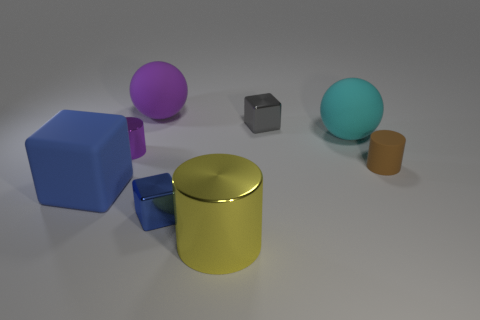Add 2 purple rubber objects. How many objects exist? 10 Subtract all balls. How many objects are left? 6 Add 2 brown rubber objects. How many brown rubber objects are left? 3 Add 4 small gray cubes. How many small gray cubes exist? 5 Subtract 1 purple balls. How many objects are left? 7 Subtract all cyan rubber spheres. Subtract all purple matte objects. How many objects are left? 6 